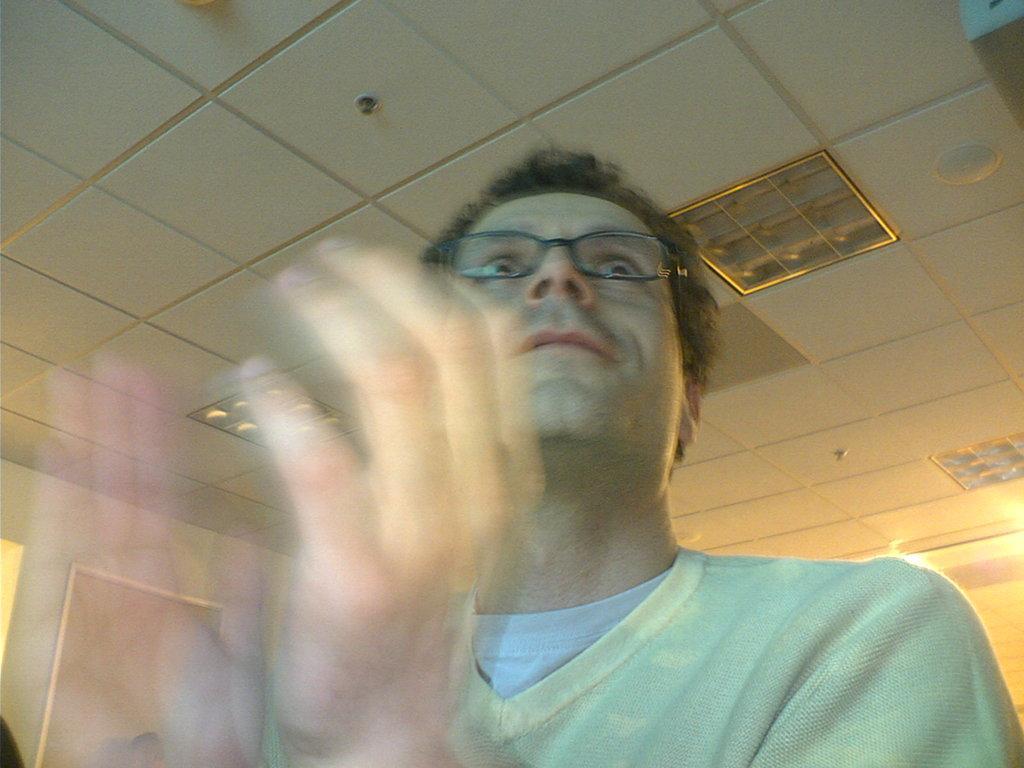How would you summarize this image in a sentence or two? The man in front of the picture wearing the white sweater is wearing the spectacles. I think he is clapping his hands. At the top, we see the lights and the ceiling of the room. This picture might be clicked in the hall. 